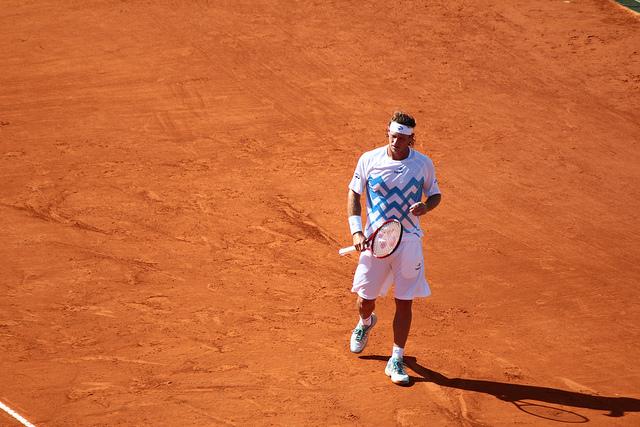Is the man dressed in a uniform?
Short answer required. Yes. Is the tennis ball in the player's hand?
Quick response, please. No. What is the color of the pitch?
Quick response, please. Brown. What is the man playing?
Keep it brief. Tennis. 